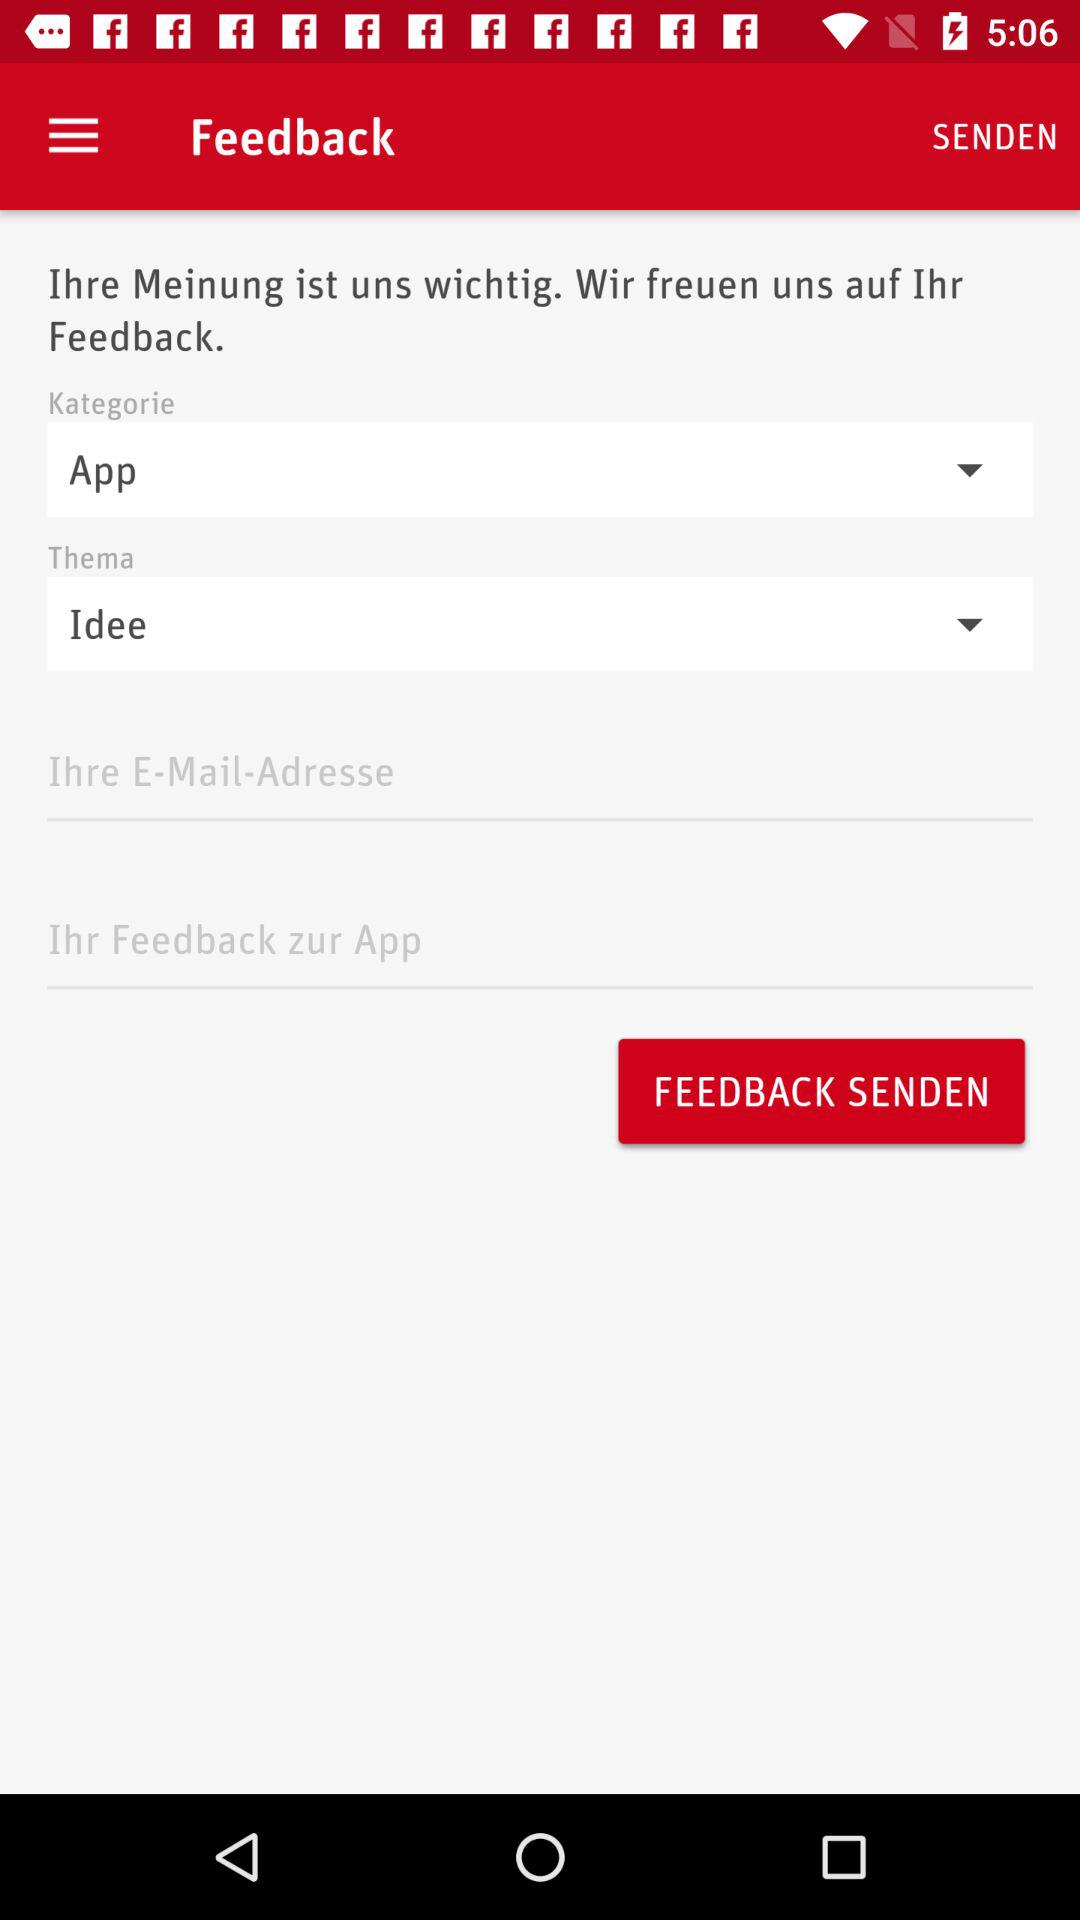How many text inputs are required to submit feedback?
Answer the question using a single word or phrase. 2 